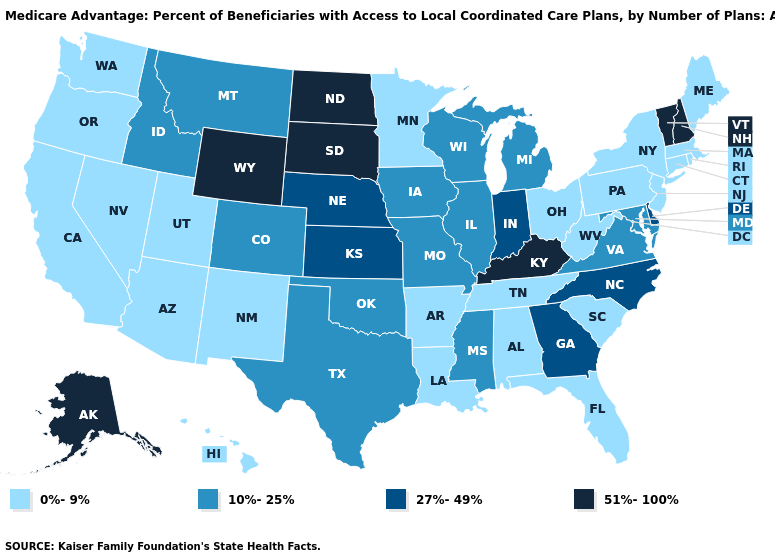Name the states that have a value in the range 27%-49%?
Keep it brief. Delaware, Georgia, Indiana, Kansas, North Carolina, Nebraska. Among the states that border South Carolina , which have the lowest value?
Be succinct. Georgia, North Carolina. Among the states that border Delaware , which have the highest value?
Short answer required. Maryland. What is the lowest value in the South?
Give a very brief answer. 0%-9%. Name the states that have a value in the range 10%-25%?
Keep it brief. Colorado, Iowa, Idaho, Illinois, Maryland, Michigan, Missouri, Mississippi, Montana, Oklahoma, Texas, Virginia, Wisconsin. Does Oregon have a higher value than California?
Short answer required. No. What is the value of California?
Keep it brief. 0%-9%. Name the states that have a value in the range 51%-100%?
Write a very short answer. Alaska, Kentucky, North Dakota, New Hampshire, South Dakota, Vermont, Wyoming. Does Montana have the same value as Nevada?
Quick response, please. No. What is the lowest value in the USA?
Concise answer only. 0%-9%. Which states have the lowest value in the USA?
Give a very brief answer. Alabama, Arkansas, Arizona, California, Connecticut, Florida, Hawaii, Louisiana, Massachusetts, Maine, Minnesota, New Jersey, New Mexico, Nevada, New York, Ohio, Oregon, Pennsylvania, Rhode Island, South Carolina, Tennessee, Utah, Washington, West Virginia. What is the highest value in the West ?
Keep it brief. 51%-100%. Name the states that have a value in the range 51%-100%?
Keep it brief. Alaska, Kentucky, North Dakota, New Hampshire, South Dakota, Vermont, Wyoming. Among the states that border Tennessee , which have the highest value?
Write a very short answer. Kentucky. Does the map have missing data?
Concise answer only. No. 